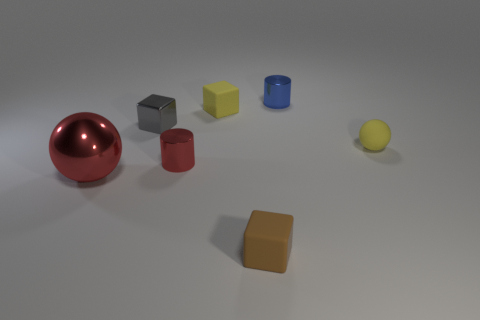Add 1 small red shiny spheres. How many objects exist? 8 Subtract all cylinders. How many objects are left? 5 Subtract all tiny yellow matte cylinders. Subtract all small blue shiny cylinders. How many objects are left? 6 Add 6 metallic cubes. How many metallic cubes are left? 7 Add 7 large cyan things. How many large cyan things exist? 7 Subtract 0 yellow cylinders. How many objects are left? 7 